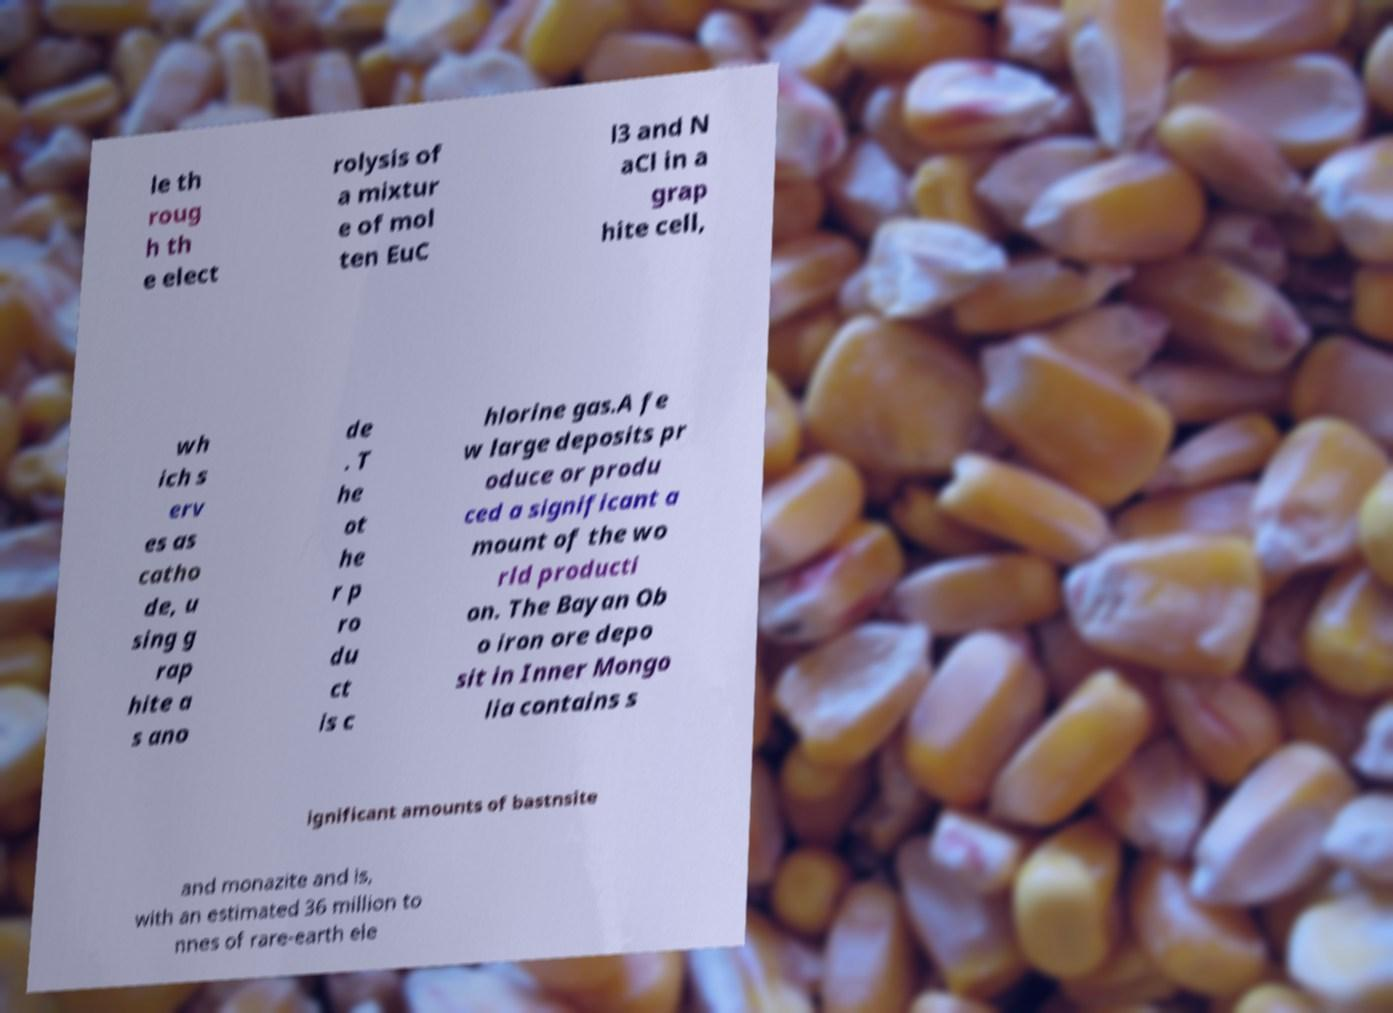Please read and relay the text visible in this image. What does it say? le th roug h th e elect rolysis of a mixtur e of mol ten EuC l3 and N aCl in a grap hite cell, wh ich s erv es as catho de, u sing g rap hite a s ano de . T he ot he r p ro du ct is c hlorine gas.A fe w large deposits pr oduce or produ ced a significant a mount of the wo rld producti on. The Bayan Ob o iron ore depo sit in Inner Mongo lia contains s ignificant amounts of bastnsite and monazite and is, with an estimated 36 million to nnes of rare-earth ele 